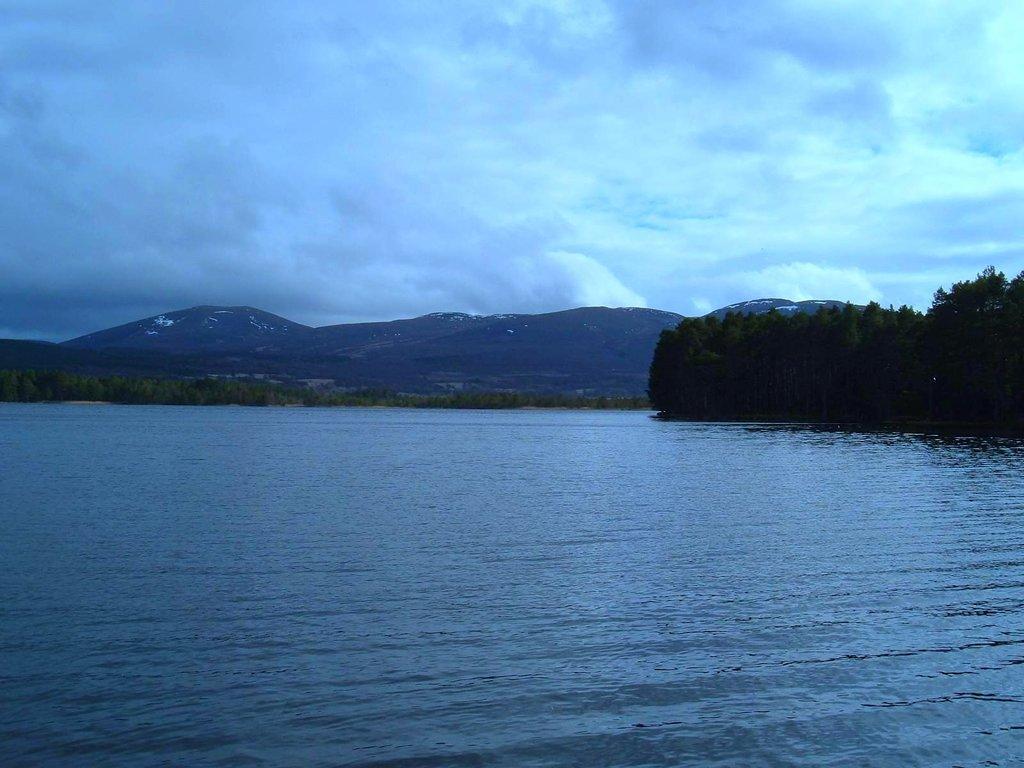Please provide a concise description of this image. In this image we can see water, trees, hills, sky and clouds. 